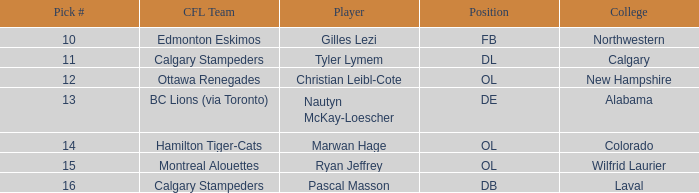What is the option number for northwestern college? 10.0. 